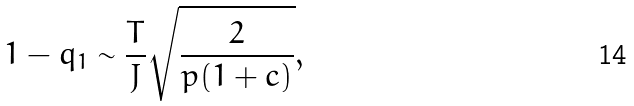Convert formula to latex. <formula><loc_0><loc_0><loc_500><loc_500>1 - q _ { 1 } \sim \frac { T } { J } \sqrt { \frac { 2 } { p ( 1 + c ) } } ,</formula> 